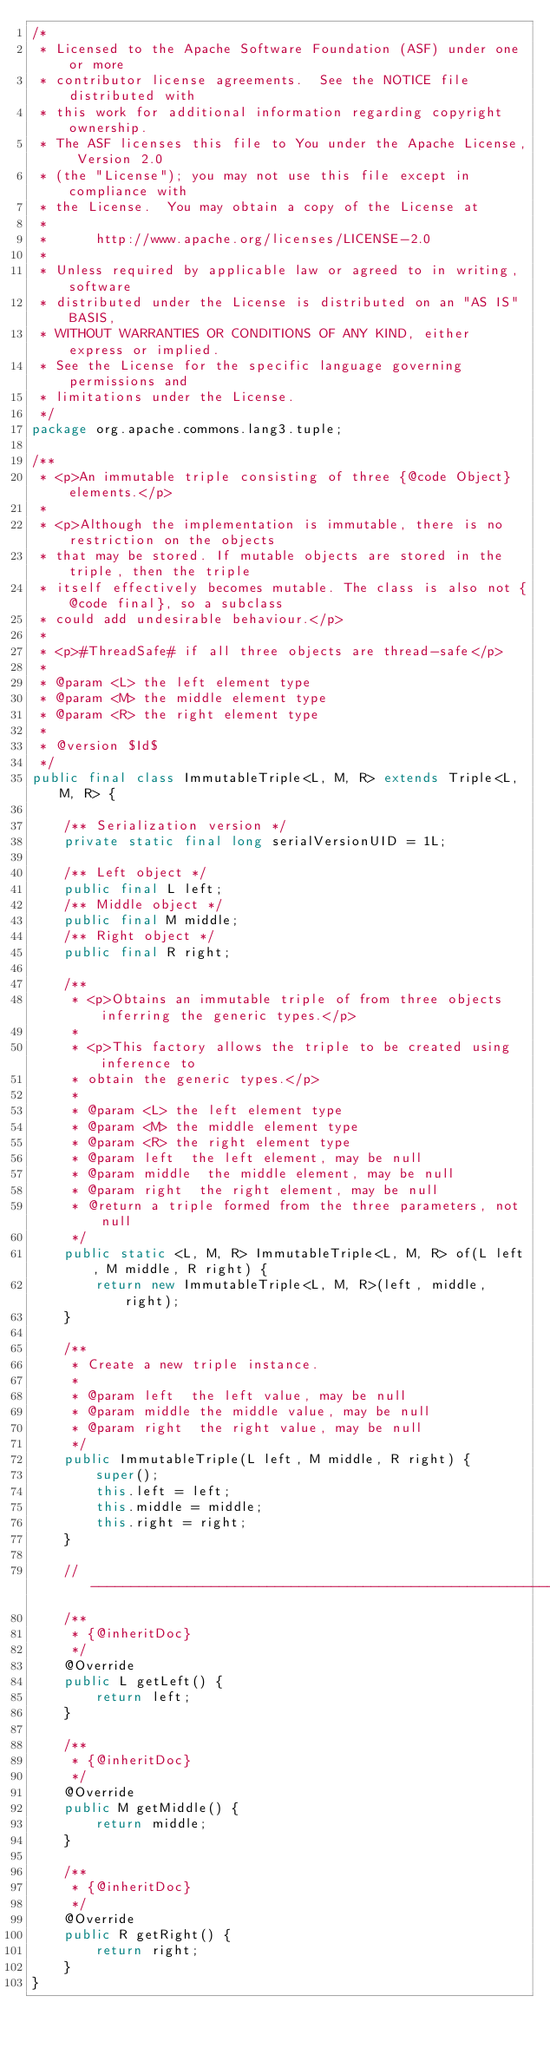<code> <loc_0><loc_0><loc_500><loc_500><_Java_>/*
 * Licensed to the Apache Software Foundation (ASF) under one or more
 * contributor license agreements.  See the NOTICE file distributed with
 * this work for additional information regarding copyright ownership.
 * The ASF licenses this file to You under the Apache License, Version 2.0
 * (the "License"); you may not use this file except in compliance with
 * the License.  You may obtain a copy of the License at
 *
 *      http://www.apache.org/licenses/LICENSE-2.0
 *
 * Unless required by applicable law or agreed to in writing, software
 * distributed under the License is distributed on an "AS IS" BASIS,
 * WITHOUT WARRANTIES OR CONDITIONS OF ANY KIND, either express or implied.
 * See the License for the specific language governing permissions and
 * limitations under the License.
 */
package org.apache.commons.lang3.tuple;

/**
 * <p>An immutable triple consisting of three {@code Object} elements.</p>
 * 
 * <p>Although the implementation is immutable, there is no restriction on the objects
 * that may be stored. If mutable objects are stored in the triple, then the triple
 * itself effectively becomes mutable. The class is also not {@code final}, so a subclass
 * could add undesirable behaviour.</p>
 * 
 * <p>#ThreadSafe# if all three objects are thread-safe</p>
 *
 * @param <L> the left element type
 * @param <M> the middle element type
 * @param <R> the right element type
 *
 * @version $Id$
 */
public final class ImmutableTriple<L, M, R> extends Triple<L, M, R> {

    /** Serialization version */
    private static final long serialVersionUID = 1L;

    /** Left object */
    public final L left;
    /** Middle object */
    public final M middle;
    /** Right object */
    public final R right;

    /**
     * <p>Obtains an immutable triple of from three objects inferring the generic types.</p>
     * 
     * <p>This factory allows the triple to be created using inference to
     * obtain the generic types.</p>
     * 
     * @param <L> the left element type
     * @param <M> the middle element type
     * @param <R> the right element type
     * @param left  the left element, may be null
     * @param middle  the middle element, may be null
     * @param right  the right element, may be null
     * @return a triple formed from the three parameters, not null
     */
    public static <L, M, R> ImmutableTriple<L, M, R> of(L left, M middle, R right) {
        return new ImmutableTriple<L, M, R>(left, middle, right);
    }

    /**
     * Create a new triple instance.
     *
     * @param left  the left value, may be null
     * @param middle the middle value, may be null
     * @param right  the right value, may be null
     */
    public ImmutableTriple(L left, M middle, R right) {
        super();
        this.left = left;
        this.middle = middle;
        this.right = right;
    }

    //-----------------------------------------------------------------------
    /**
     * {@inheritDoc}
     */
    @Override
    public L getLeft() {
        return left;
    }

    /**
     * {@inheritDoc}
     */
    @Override
    public M getMiddle() {
        return middle;
    }

    /**
     * {@inheritDoc}
     */
    @Override
    public R getRight() {
        return right;
    }
}

</code> 